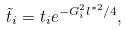<formula> <loc_0><loc_0><loc_500><loc_500>\tilde { t } _ { i } = t _ { i } e ^ { - G _ { i } ^ { 2 } l ^ { * 2 } / 4 } ,</formula> 